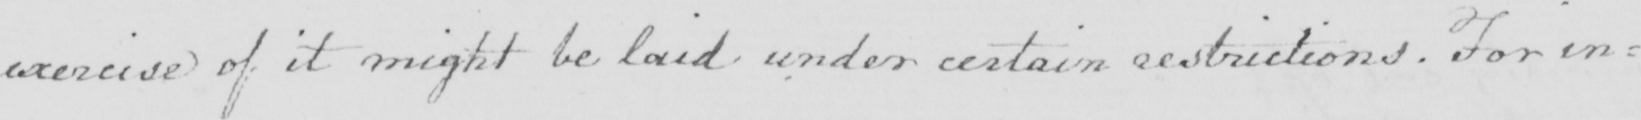What text is written in this handwritten line? exercise of it might be laid under certain restrictions  . For in= 